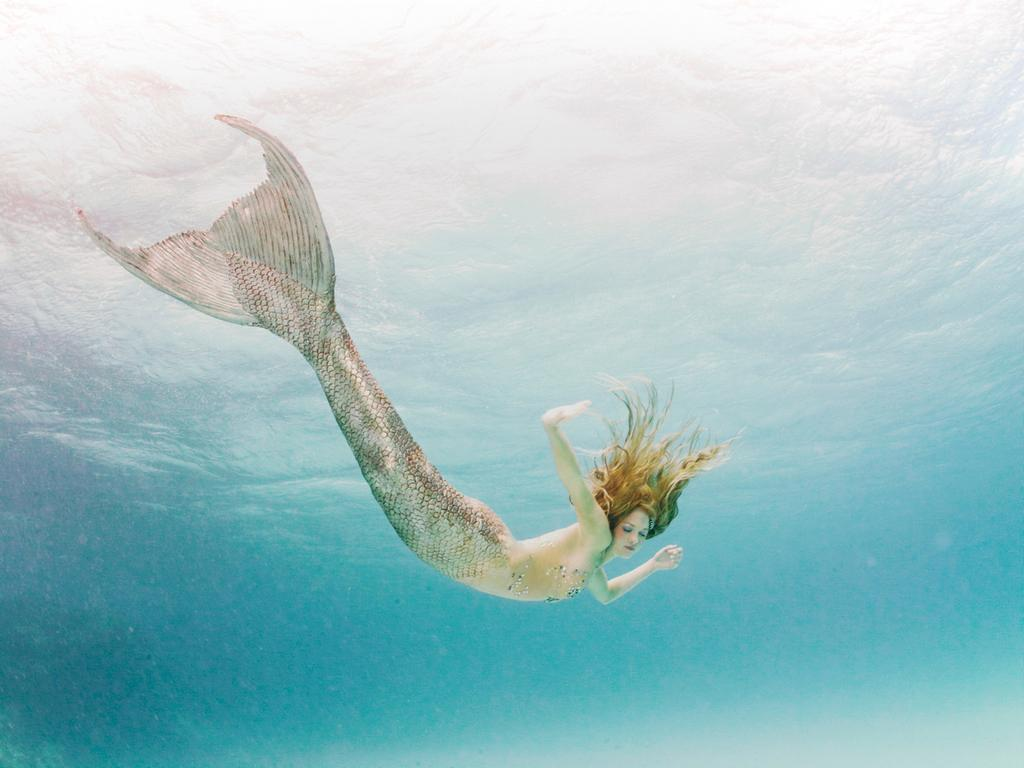What mythical creature is depicted in the image? There is a mermaid in the image. What color is the water in the image? The water in the image is blue. What type of news is being read by the mermaid in the image? There is no news or reading material present in the image; it only features a mermaid in blue water. 